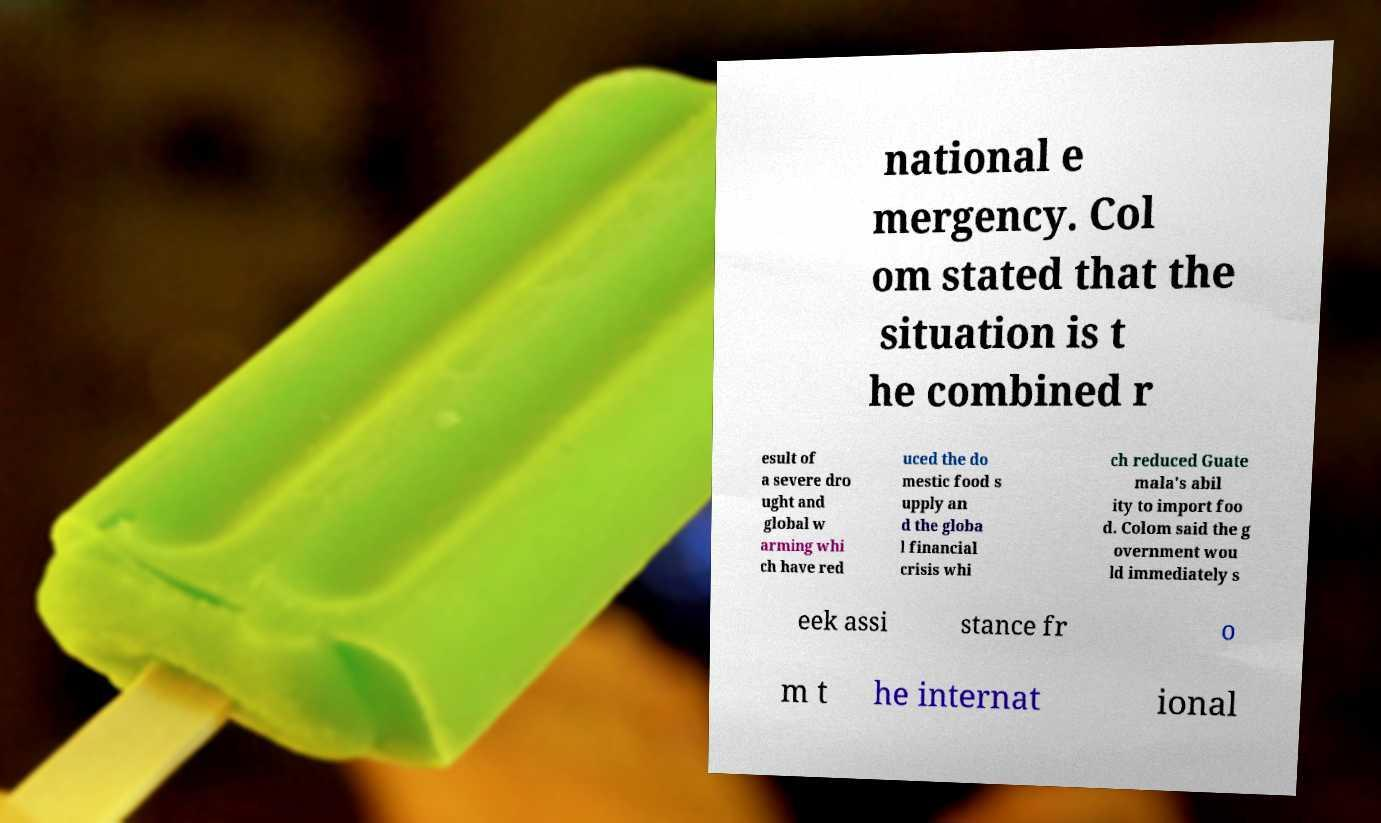Please read and relay the text visible in this image. What does it say? national e mergency. Col om stated that the situation is t he combined r esult of a severe dro ught and global w arming whi ch have red uced the do mestic food s upply an d the globa l financial crisis whi ch reduced Guate mala's abil ity to import foo d. Colom said the g overnment wou ld immediately s eek assi stance fr o m t he internat ional 